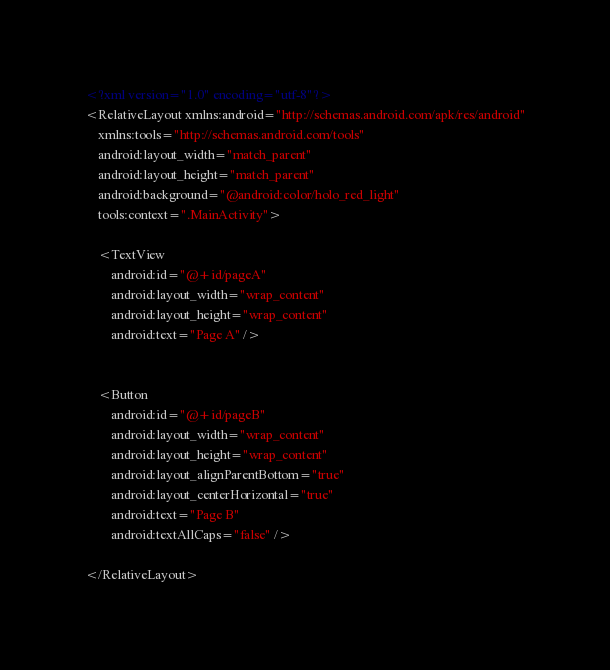<code> <loc_0><loc_0><loc_500><loc_500><_XML_><?xml version="1.0" encoding="utf-8"?>
<RelativeLayout xmlns:android="http://schemas.android.com/apk/res/android"
    xmlns:tools="http://schemas.android.com/tools"
    android:layout_width="match_parent"
    android:layout_height="match_parent"
    android:background="@android:color/holo_red_light"
    tools:context=".MainActivity">

    <TextView
        android:id="@+id/pageA"
        android:layout_width="wrap_content"
        android:layout_height="wrap_content"
        android:text="Page A" />


    <Button
        android:id="@+id/pageB"
        android:layout_width="wrap_content"
        android:layout_height="wrap_content"
        android:layout_alignParentBottom="true"
        android:layout_centerHorizontal="true"
        android:text="Page B"
        android:textAllCaps="false" />

</RelativeLayout></code> 